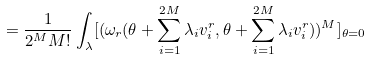<formula> <loc_0><loc_0><loc_500><loc_500>= \frac { 1 } { 2 ^ { M } M ! } \int _ { \lambda } [ ( \omega _ { r } ( \theta + \sum _ { i = 1 } ^ { 2 M } \lambda _ { i } v _ { i } ^ { r } , \theta + \sum _ { i = 1 } ^ { 2 M } \lambda _ { i } v _ { i } ^ { r } ) ) ^ { M } ] _ { \theta = 0 }</formula> 